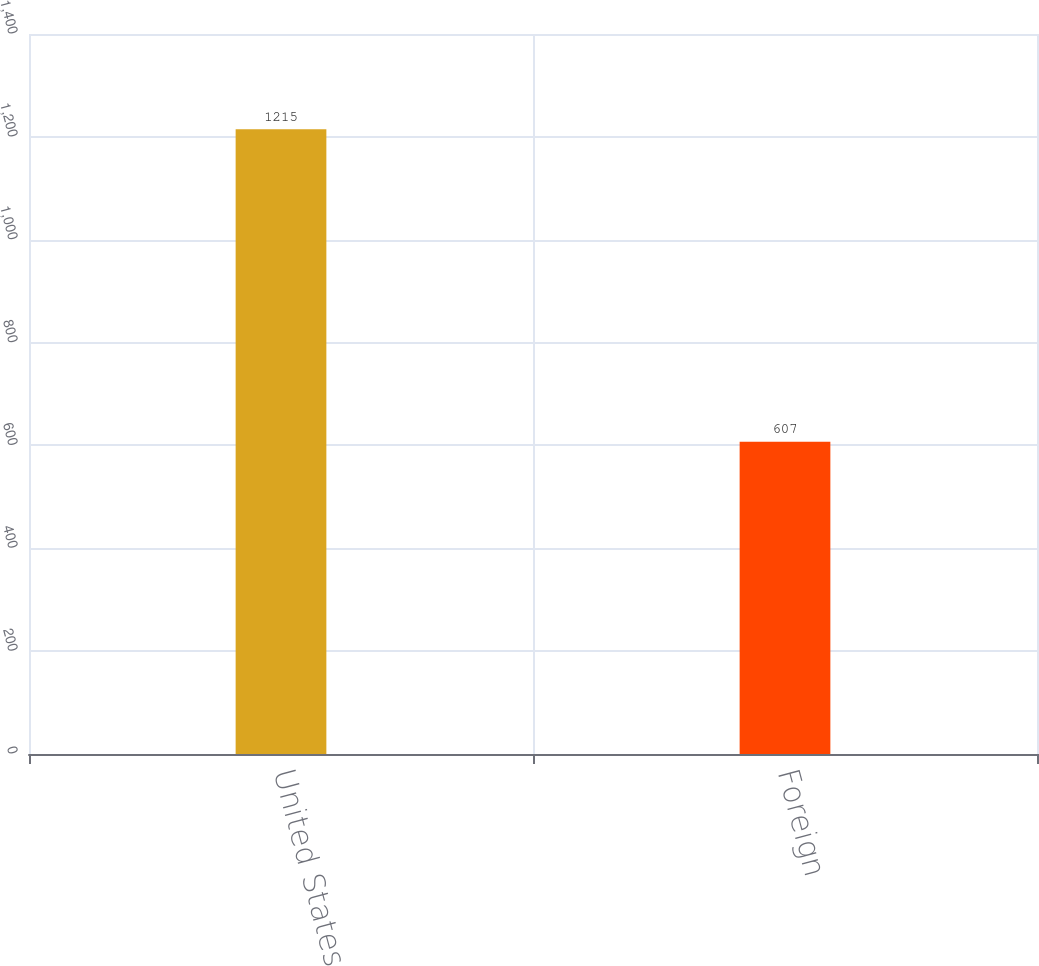<chart> <loc_0><loc_0><loc_500><loc_500><bar_chart><fcel>United States<fcel>Foreign<nl><fcel>1215<fcel>607<nl></chart> 